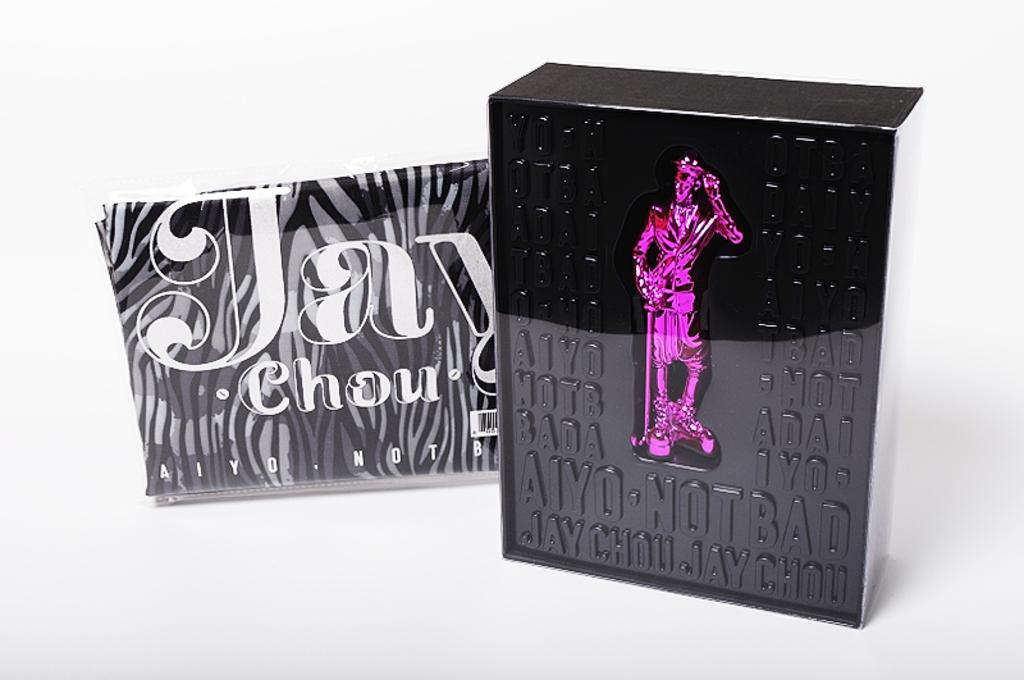What is the main subject in the foreground of the image? There is a black box in the foreground of the image. What color is the background of the image? The background of the image is white. Can you see any trails left by the black box in the image? There are no trails visible in the image; it only shows the black box in the foreground and the white background. Is there any agreement between the black box and the white background in the image? There is no indication of any agreement between the black box and the white background in the image. 